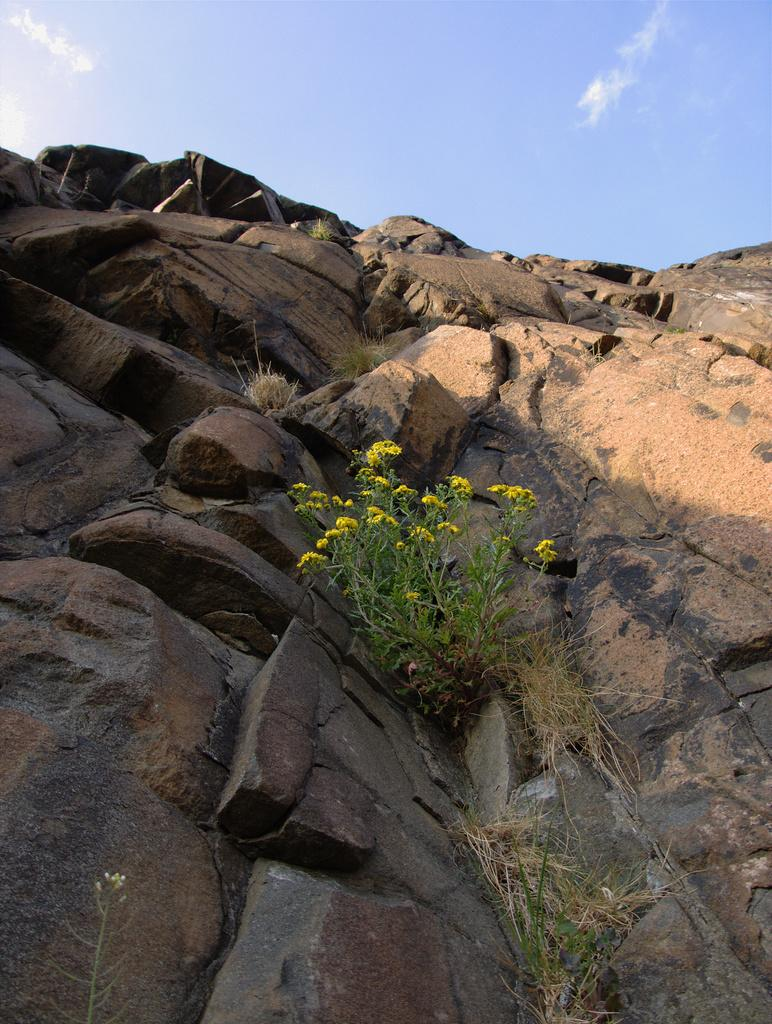What type of vegetation can be seen in the image? There is grass and flowering plants in the image. What type of natural landform is visible in the image? There are mountains in the image. What part of the natural environment is visible in the image? The sky is visible in the image. Based on the presence of the sky and the absence of artificial lighting, when might this image have been taken? The image was likely taken during the day. Can you tell me how many zebras are grazing in the grass in the image? There are no zebras present in the image; it features grass, flowering plants, mountains, and the sky. What type of map is shown on the mountains in the image? There is no map present in the image; it features grass, flowering plants, mountains, and the sky. 